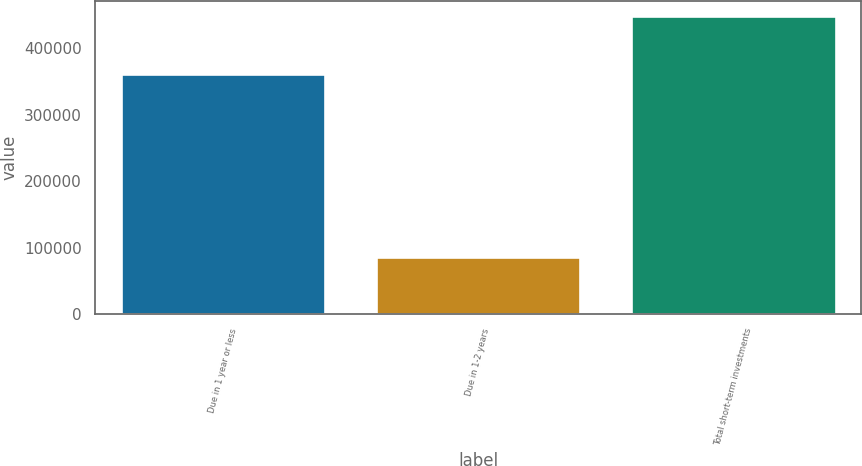Convert chart to OTSL. <chart><loc_0><loc_0><loc_500><loc_500><bar_chart><fcel>Due in 1 year or less<fcel>Due in 1-2 years<fcel>Total short-term investments<nl><fcel>362259<fcel>86682<fcel>448941<nl></chart> 